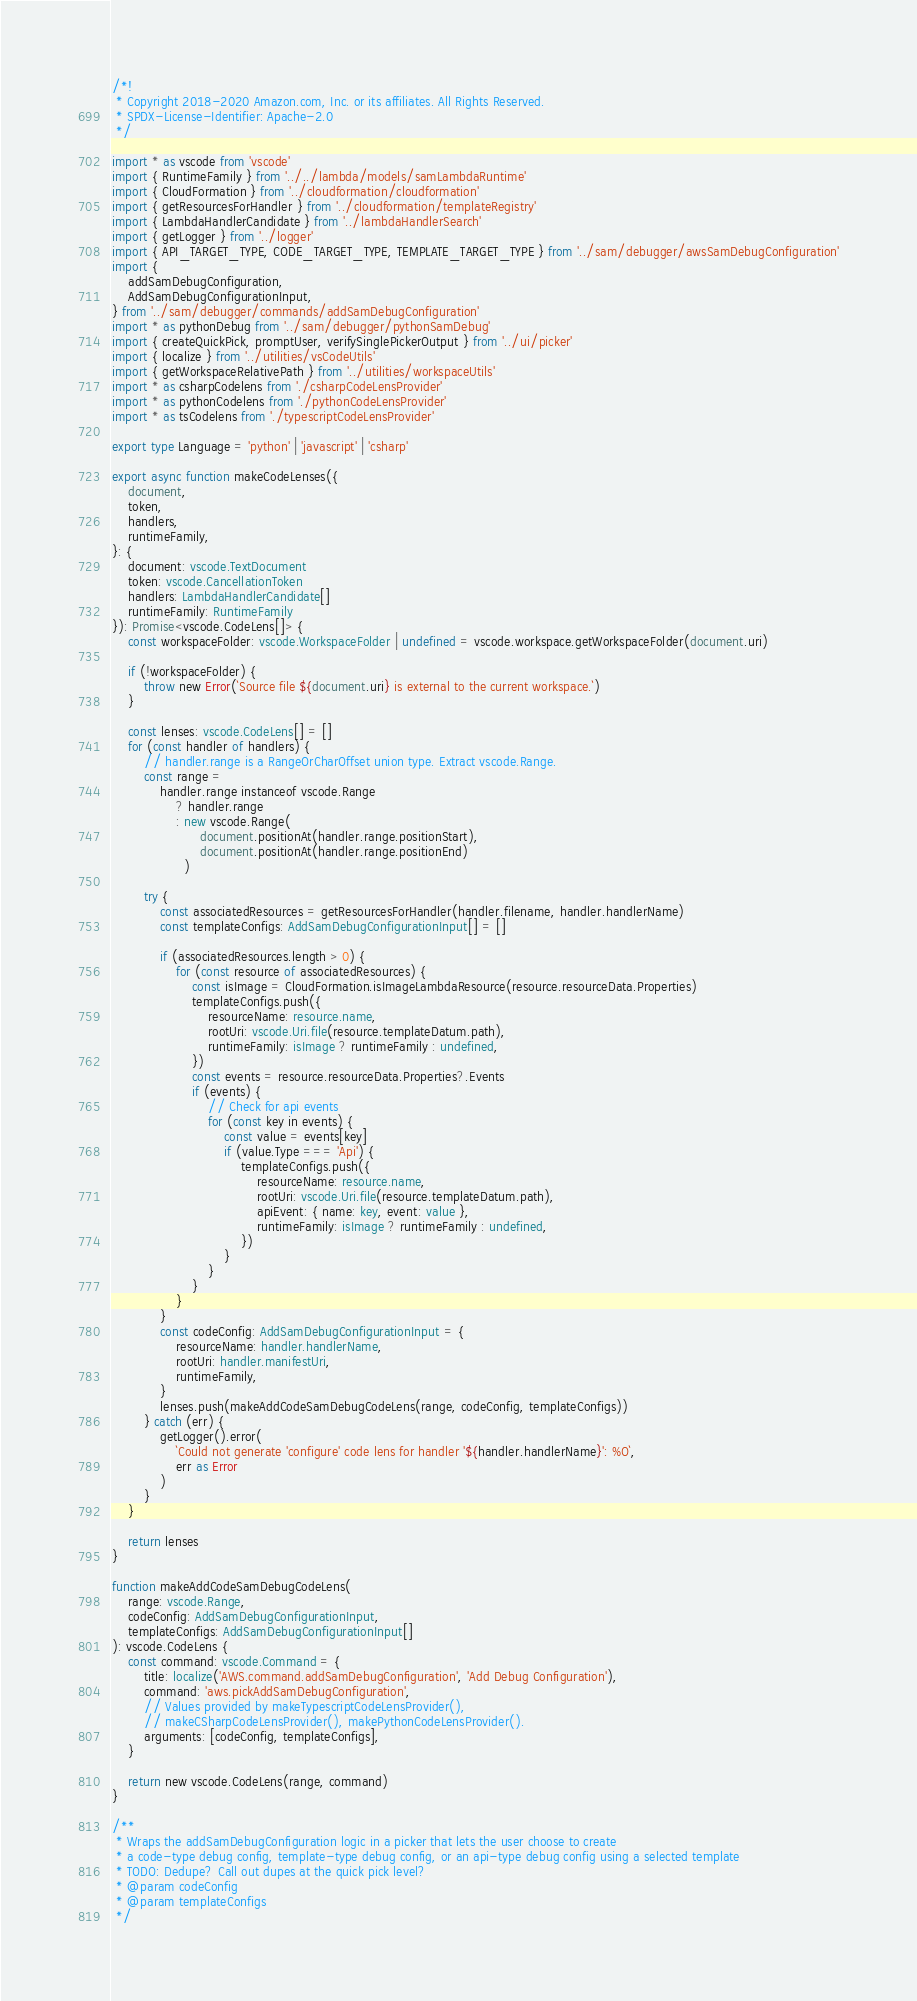<code> <loc_0><loc_0><loc_500><loc_500><_TypeScript_>/*!
 * Copyright 2018-2020 Amazon.com, Inc. or its affiliates. All Rights Reserved.
 * SPDX-License-Identifier: Apache-2.0
 */

import * as vscode from 'vscode'
import { RuntimeFamily } from '../../lambda/models/samLambdaRuntime'
import { CloudFormation } from '../cloudformation/cloudformation'
import { getResourcesForHandler } from '../cloudformation/templateRegistry'
import { LambdaHandlerCandidate } from '../lambdaHandlerSearch'
import { getLogger } from '../logger'
import { API_TARGET_TYPE, CODE_TARGET_TYPE, TEMPLATE_TARGET_TYPE } from '../sam/debugger/awsSamDebugConfiguration'
import {
    addSamDebugConfiguration,
    AddSamDebugConfigurationInput,
} from '../sam/debugger/commands/addSamDebugConfiguration'
import * as pythonDebug from '../sam/debugger/pythonSamDebug'
import { createQuickPick, promptUser, verifySinglePickerOutput } from '../ui/picker'
import { localize } from '../utilities/vsCodeUtils'
import { getWorkspaceRelativePath } from '../utilities/workspaceUtils'
import * as csharpCodelens from './csharpCodeLensProvider'
import * as pythonCodelens from './pythonCodeLensProvider'
import * as tsCodelens from './typescriptCodeLensProvider'

export type Language = 'python' | 'javascript' | 'csharp'

export async function makeCodeLenses({
    document,
    token,
    handlers,
    runtimeFamily,
}: {
    document: vscode.TextDocument
    token: vscode.CancellationToken
    handlers: LambdaHandlerCandidate[]
    runtimeFamily: RuntimeFamily
}): Promise<vscode.CodeLens[]> {
    const workspaceFolder: vscode.WorkspaceFolder | undefined = vscode.workspace.getWorkspaceFolder(document.uri)

    if (!workspaceFolder) {
        throw new Error(`Source file ${document.uri} is external to the current workspace.`)
    }

    const lenses: vscode.CodeLens[] = []
    for (const handler of handlers) {
        // handler.range is a RangeOrCharOffset union type. Extract vscode.Range.
        const range =
            handler.range instanceof vscode.Range
                ? handler.range
                : new vscode.Range(
                      document.positionAt(handler.range.positionStart),
                      document.positionAt(handler.range.positionEnd)
                  )

        try {
            const associatedResources = getResourcesForHandler(handler.filename, handler.handlerName)
            const templateConfigs: AddSamDebugConfigurationInput[] = []

            if (associatedResources.length > 0) {
                for (const resource of associatedResources) {
                    const isImage = CloudFormation.isImageLambdaResource(resource.resourceData.Properties)
                    templateConfigs.push({
                        resourceName: resource.name,
                        rootUri: vscode.Uri.file(resource.templateDatum.path),
                        runtimeFamily: isImage ? runtimeFamily : undefined,
                    })
                    const events = resource.resourceData.Properties?.Events
                    if (events) {
                        // Check for api events
                        for (const key in events) {
                            const value = events[key]
                            if (value.Type === 'Api') {
                                templateConfigs.push({
                                    resourceName: resource.name,
                                    rootUri: vscode.Uri.file(resource.templateDatum.path),
                                    apiEvent: { name: key, event: value },
                                    runtimeFamily: isImage ? runtimeFamily : undefined,
                                })
                            }
                        }
                    }
                }
            }
            const codeConfig: AddSamDebugConfigurationInput = {
                resourceName: handler.handlerName,
                rootUri: handler.manifestUri,
                runtimeFamily,
            }
            lenses.push(makeAddCodeSamDebugCodeLens(range, codeConfig, templateConfigs))
        } catch (err) {
            getLogger().error(
                `Could not generate 'configure' code lens for handler '${handler.handlerName}': %O`,
                err as Error
            )
        }
    }

    return lenses
}

function makeAddCodeSamDebugCodeLens(
    range: vscode.Range,
    codeConfig: AddSamDebugConfigurationInput,
    templateConfigs: AddSamDebugConfigurationInput[]
): vscode.CodeLens {
    const command: vscode.Command = {
        title: localize('AWS.command.addSamDebugConfiguration', 'Add Debug Configuration'),
        command: 'aws.pickAddSamDebugConfiguration',
        // Values provided by makeTypescriptCodeLensProvider(),
        // makeCSharpCodeLensProvider(), makePythonCodeLensProvider().
        arguments: [codeConfig, templateConfigs],
    }

    return new vscode.CodeLens(range, command)
}

/**
 * Wraps the addSamDebugConfiguration logic in a picker that lets the user choose to create
 * a code-type debug config, template-type debug config, or an api-type debug config using a selected template
 * TODO: Dedupe? Call out dupes at the quick pick level?
 * @param codeConfig
 * @param templateConfigs
 */</code> 